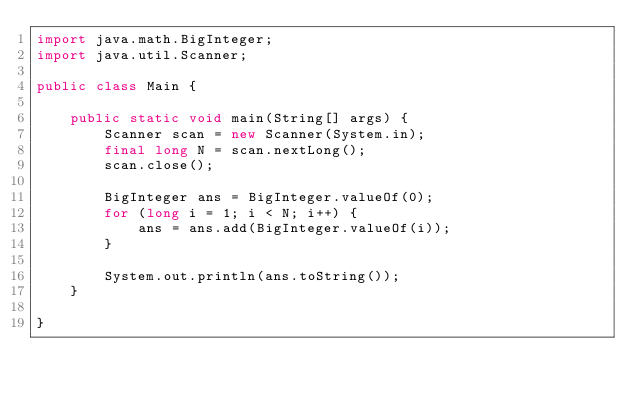<code> <loc_0><loc_0><loc_500><loc_500><_Java_>import java.math.BigInteger;
import java.util.Scanner;

public class Main {

    public static void main(String[] args) {
        Scanner scan = new Scanner(System.in);
        final long N = scan.nextLong();
        scan.close();

        BigInteger ans = BigInteger.valueOf(0);
        for (long i = 1; i < N; i++) {
            ans = ans.add(BigInteger.valueOf(i));
        }

        System.out.println(ans.toString());
    }

}
</code> 